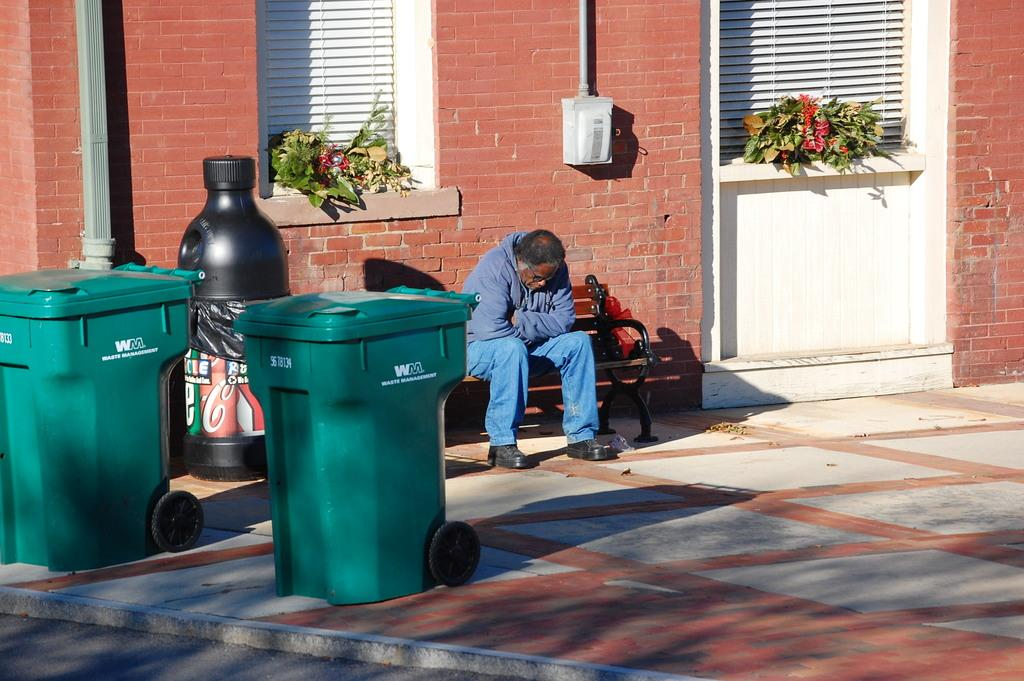Provide a one-sentence caption for the provided image. A man sits on a bench near two green, WM labeled trash cans. 